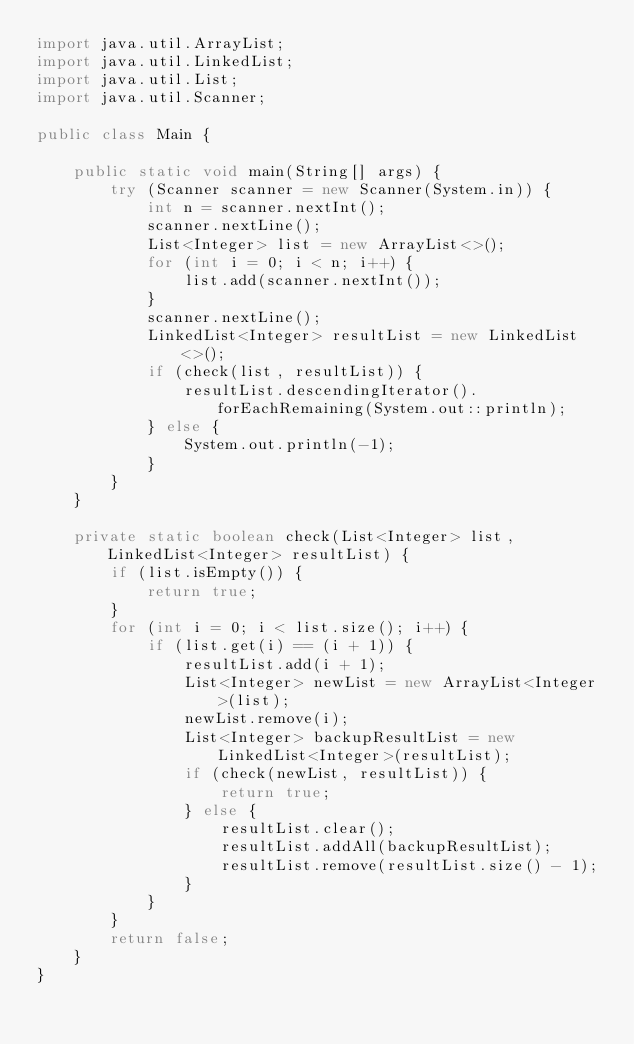Convert code to text. <code><loc_0><loc_0><loc_500><loc_500><_Java_>import java.util.ArrayList;
import java.util.LinkedList;
import java.util.List;
import java.util.Scanner;

public class Main {

	public static void main(String[] args) {
		try (Scanner scanner = new Scanner(System.in)) {
			int n = scanner.nextInt();
			scanner.nextLine();
			List<Integer> list = new ArrayList<>();
			for (int i = 0; i < n; i++) {
				list.add(scanner.nextInt());
			}
			scanner.nextLine();
			LinkedList<Integer> resultList = new LinkedList<>();
			if (check(list, resultList)) {
				resultList.descendingIterator().forEachRemaining(System.out::println);
			} else {
				System.out.println(-1);
			}
		}
	}

	private static boolean check(List<Integer> list, LinkedList<Integer> resultList) {
		if (list.isEmpty()) {
			return true;
		}
		for (int i = 0; i < list.size(); i++) {
			if (list.get(i) == (i + 1)) {
				resultList.add(i + 1);
				List<Integer> newList = new ArrayList<Integer>(list);
				newList.remove(i);
				List<Integer> backupResultList = new LinkedList<Integer>(resultList);
				if (check(newList, resultList)) {
					return true;
				} else {
					resultList.clear();
					resultList.addAll(backupResultList);
					resultList.remove(resultList.size() - 1);
				}
			}
		}
		return false;
	}
}</code> 